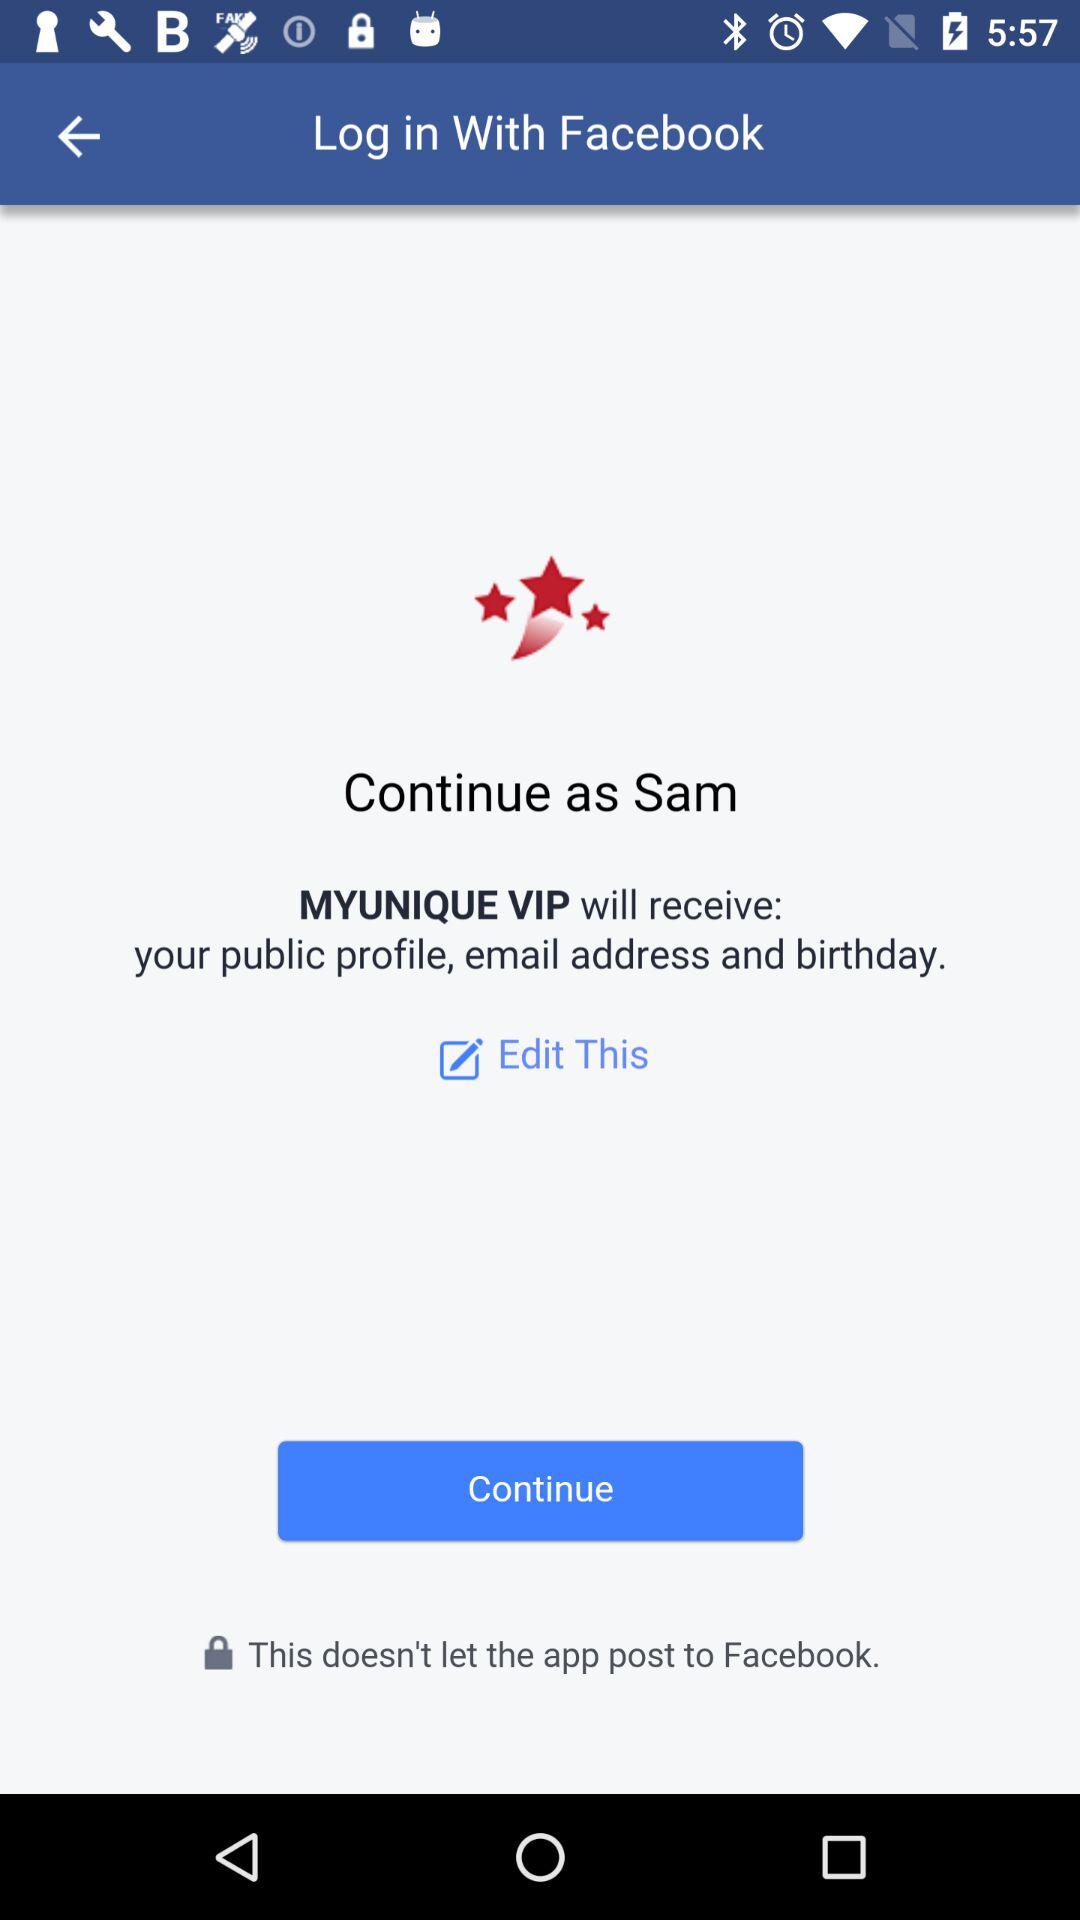What application will receive the public figure and email address? The application that will receive the information is "MYUNIQUE VIP". 